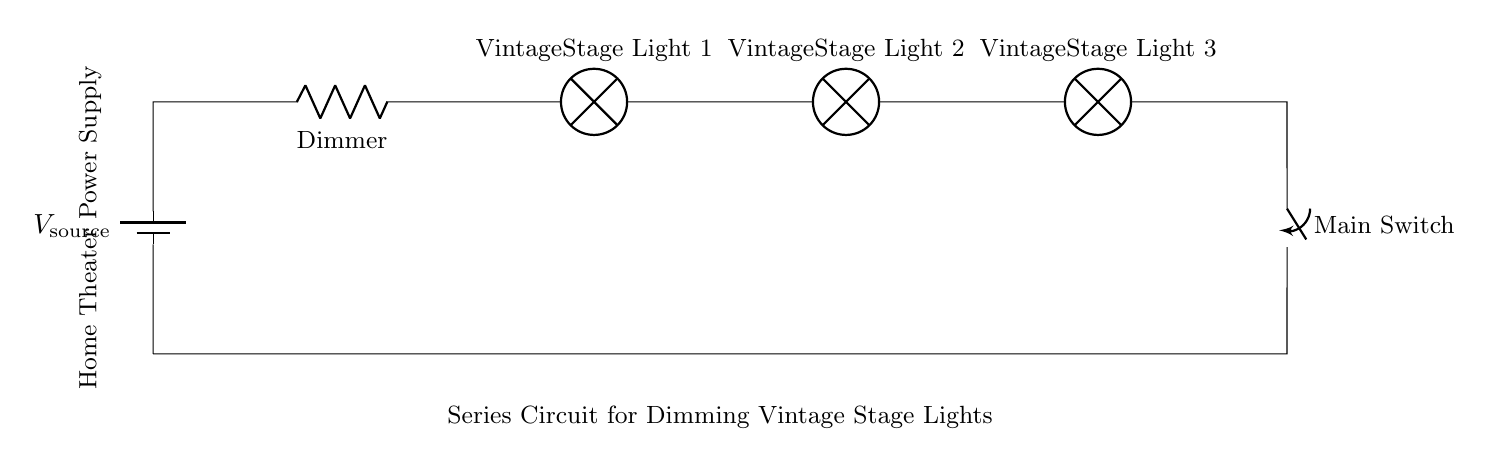What type of circuit is shown? The circuit illustrated is a series circuit, which can be identified by the single path for current to flow through all components sequentially.
Answer: series circuit How many vintage stage lights are in the circuit? The circuit includes three vintage stage lights, as indicated by the labels on the components within the diagram.
Answer: three What component is used to dim the lights? A resistor labeled as the dimmer is used to control the brightness of the vintage stage lights by limiting the current flowing through them.
Answer: Dimmer What is the function of the main switch? The main switch serves to turn the entire circuit on or off, controlling power to all components in the series simultaneously.
Answer: on/off control If one light bulb burns out, what happens to the others? In a series circuit, if one light bulb burns out, the circuit is broken, and all lights will go out since the current has only one path to follow and that path is interrupted.
Answer: All lights go out What type of power supply is used in the circuit? The circuit is powered by a battery, as represented by the component labeled as voltage source in the diagram.
Answer: battery Where is the power supply located? The power supply is located at the start of the circuit, denoted at the position labeled as "Home Theater Power Supply" in the diagram.
Answer: Start of the circuit 